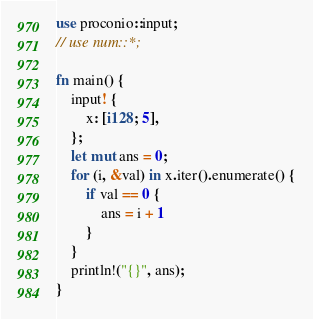<code> <loc_0><loc_0><loc_500><loc_500><_Rust_>use proconio::input;
// use num::*;

fn main() {
    input! {
        x: [i128; 5],
    };
    let mut ans = 0;
    for (i, &val) in x.iter().enumerate() {
        if val == 0 {
            ans = i + 1
        }
    }
    println!("{}", ans);
}
</code> 